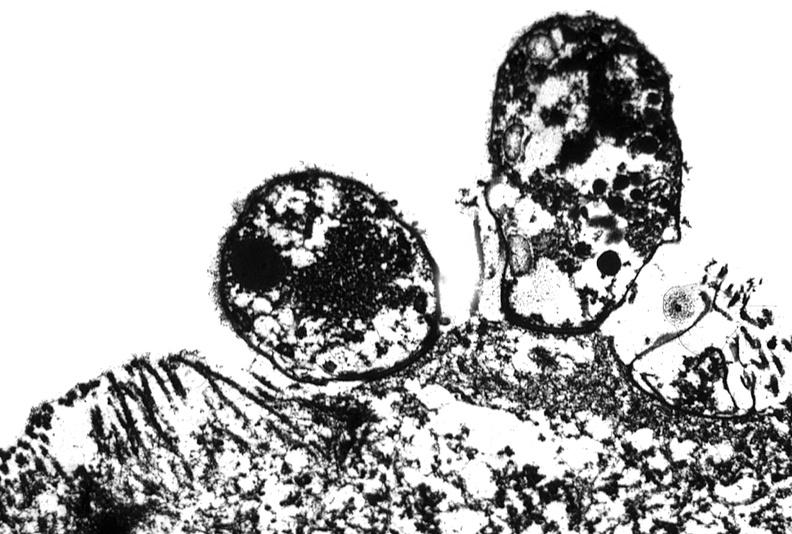does this image show colon biopsy, cryptosporidia?
Answer the question using a single word or phrase. Yes 